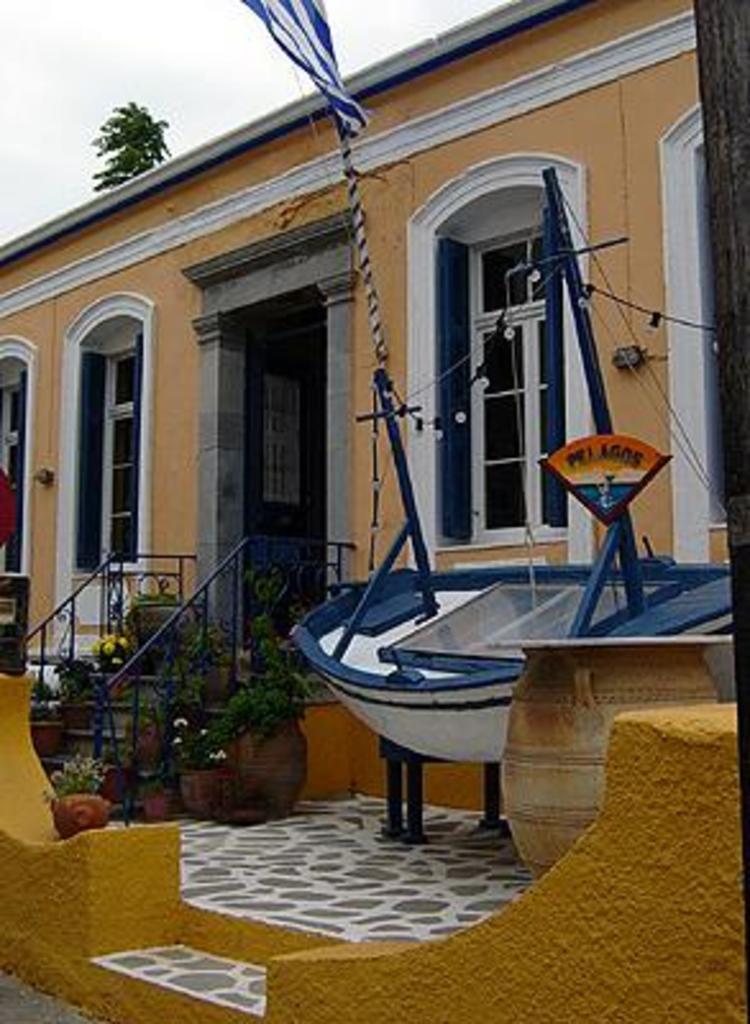In one or two sentences, can you explain what this image depicts? In this image there is a house, in front of it there is a staircase which has plants on it and there is a boat and a few other objects, in the background there is a tree. 